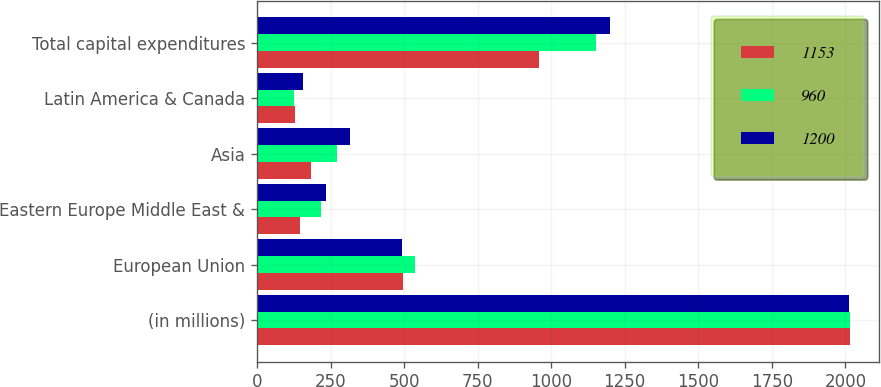<chart> <loc_0><loc_0><loc_500><loc_500><stacked_bar_chart><ecel><fcel>(in millions)<fcel>European Union<fcel>Eastern Europe Middle East &<fcel>Asia<fcel>Latin America & Canada<fcel>Total capital expenditures<nl><fcel>1153<fcel>2015<fcel>497<fcel>147<fcel>185<fcel>130<fcel>960<nl><fcel>960<fcel>2014<fcel>537<fcel>216<fcel>272<fcel>125<fcel>1153<nl><fcel>1200<fcel>2013<fcel>493<fcel>234<fcel>317<fcel>156<fcel>1200<nl></chart> 